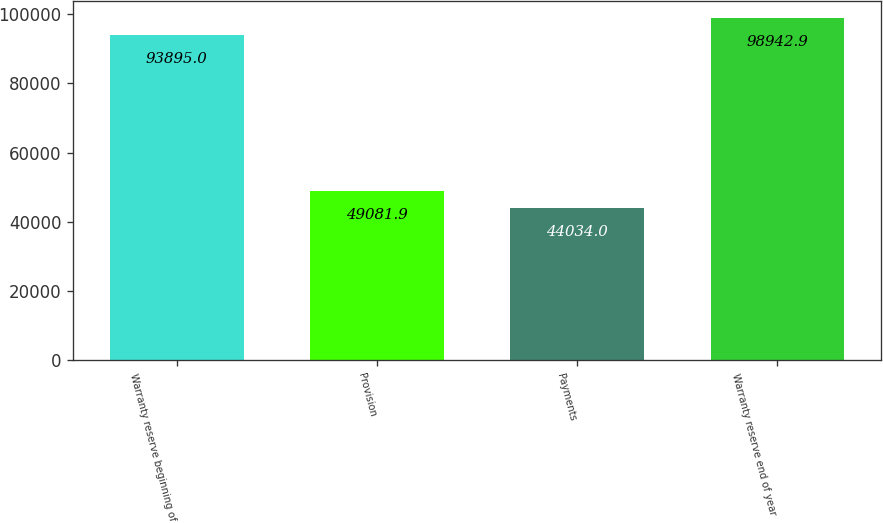<chart> <loc_0><loc_0><loc_500><loc_500><bar_chart><fcel>Warranty reserve beginning of<fcel>Provision<fcel>Payments<fcel>Warranty reserve end of year<nl><fcel>93895<fcel>49081.9<fcel>44034<fcel>98942.9<nl></chart> 